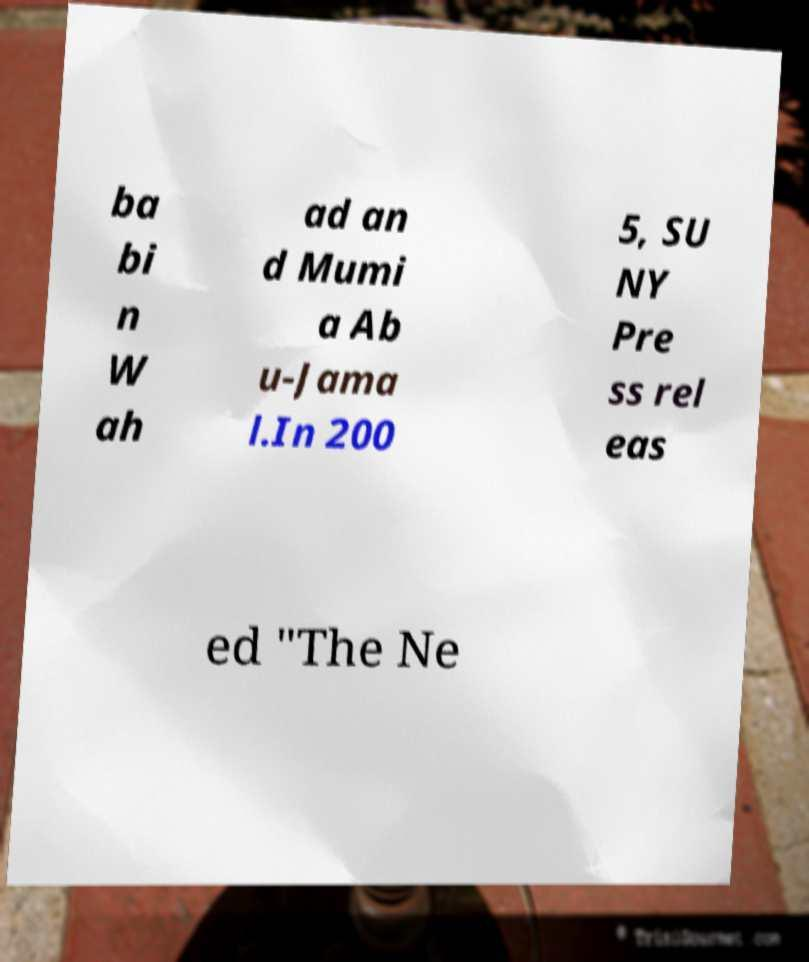Can you accurately transcribe the text from the provided image for me? ba bi n W ah ad an d Mumi a Ab u-Jama l.In 200 5, SU NY Pre ss rel eas ed "The Ne 